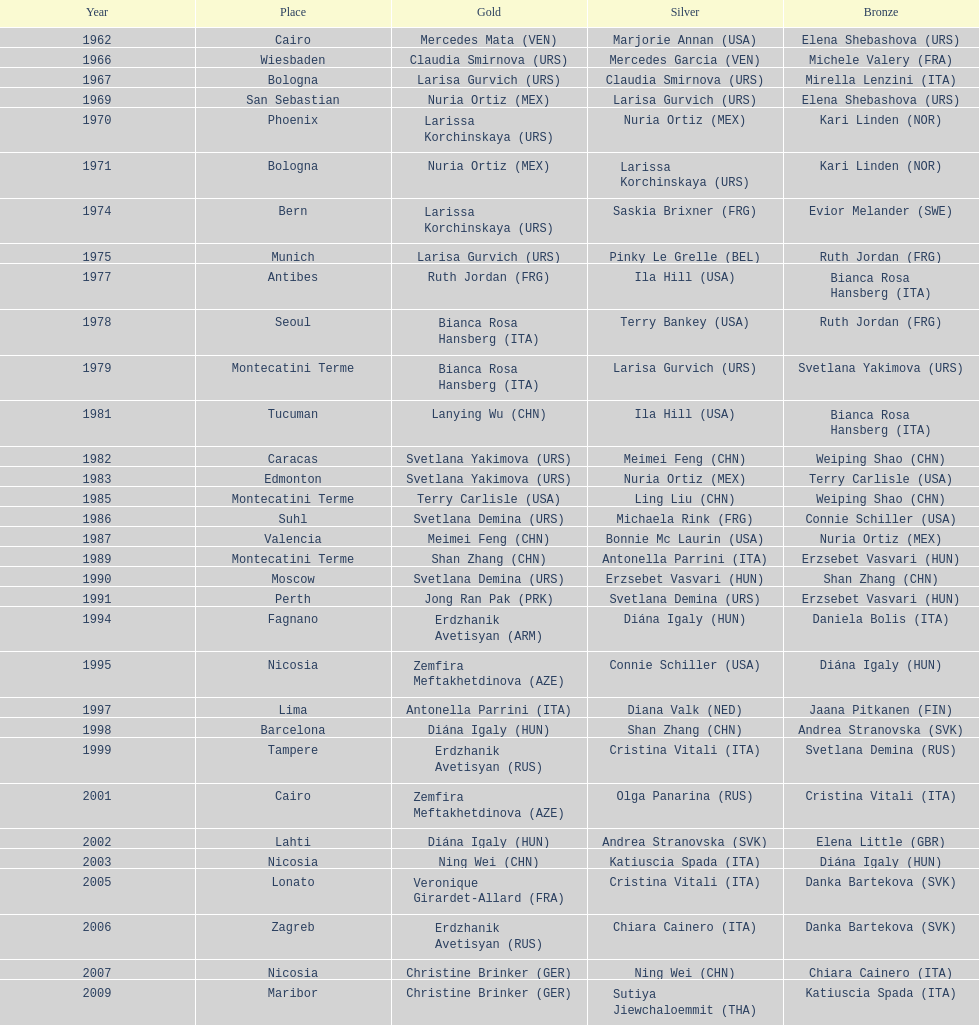Between china and mexico, which nation has secured a higher number of gold medals? China. 